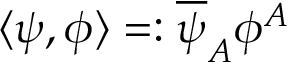<formula> <loc_0><loc_0><loc_500><loc_500>\langle \psi , \phi \rangle = \colon \overline { \psi } _ { A } \phi ^ { A }</formula> 